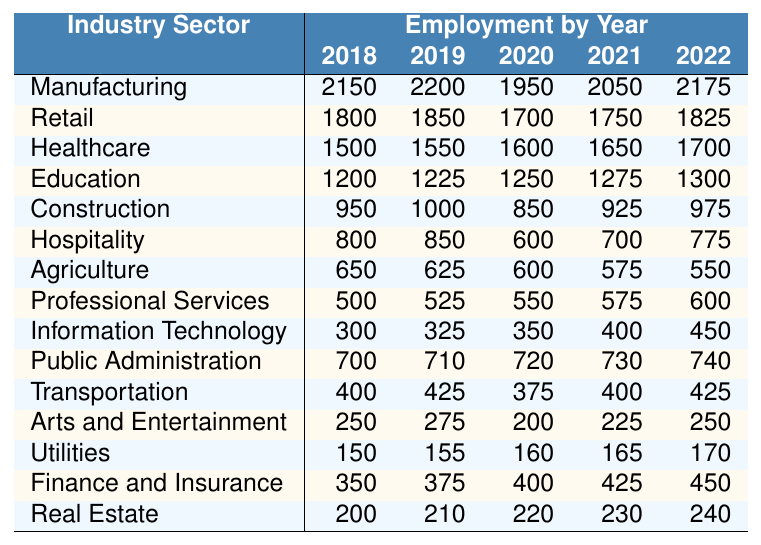What was the employment figure for the Retail sector in 2020? The table shows the employment figure for the Retail sector for each year. In 2020, the figure is specifically listed as 1700.
Answer: 1700 Which industry sector had the highest employment in 2019? By looking at the employment figures for each sector in 2019, Manufacturing had the highest employment at 2200.
Answer: Manufacturing What was the percentage decrease in employment for the Hospitality sector from 2019 to 2020? The employment figure for Hospitality in 2019 was 850, and in 2020 it decreased to 600. The decrease is 850 - 600 = 250. To find the percentage decrease, divide 250 by 850 and multiply by 100: (250/850) * 100 = 29.41%.
Answer: 29.41% Did Public Administration's employment increase over the years 2018 to 2022? By checking the employment figures for Public Administration from 2018 to 2022, we see they are 700, 710, 720, 730, and 740, respectively. Since all figures are higher than the previous year, it indicates an increase.
Answer: Yes What is the average employment for the Agriculture sector over the five years? The employment figures for Agriculture are 650, 625, 600, 575, and 550. Summing these gives 650 + 625 + 600 + 575 + 550 = 3075. To find the average, we divide by 5: 3075 / 5 = 615.
Answer: 615 Which two sectors had the lowest employment figures in 2022? Looking at the 2022 figures, Agriculture had 550, and Arts and Entertainment had 250. Comparing all sectors, these two are the lowest.
Answer: Agriculture and Arts and Entertainment What was the total employment for all sectors combined in 2021? Totaling the employment figures for all sectors in 2021, we compute: 2050 (Manufacturing) + 1750 (Retail) + 1650 (Healthcare) + 1275 (Education) + 925 (Construction) + 700 (Hospitality) + 575 (Agriculture) + 575 (Professional Services) + 400 (Information Technology) + 730 (Public Administration) + 400 (Transportation) + 225 (Arts and Entertainment) + 165 (Utilities) + 425 (Finance and Insurance) + 230 (Real Estate) equals 11615.
Answer: 11615 Was the employment in the Finance and Insurance sector higher in 2022 than in 2018? The employment figures for Finance and Insurance are 350 in 2018 and 450 in 2022. Since 450 is greater than 350, the employment has increased over these years.
Answer: Yes Calculate the change in employment for the Construction sector from 2018 to 2022. The employment for Construction in 2018 was 950 and in 2022 it was 975. The change is calculated as 975 - 950 = 25, indicating an increase.
Answer: 25 Which sector experienced the most significant decline in employment from 2018 to 2022? By inspecting the figures, Agriculture went from 650 in 2018 to 550 in 2022, a decline of 100. Comparing this to other sectors, this is the largest decline observed.
Answer: Agriculture 